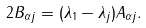<formula> <loc_0><loc_0><loc_500><loc_500>2 B _ { \alpha j } = ( \lambda _ { 1 } - \lambda _ { j } ) A _ { \alpha j } .</formula> 